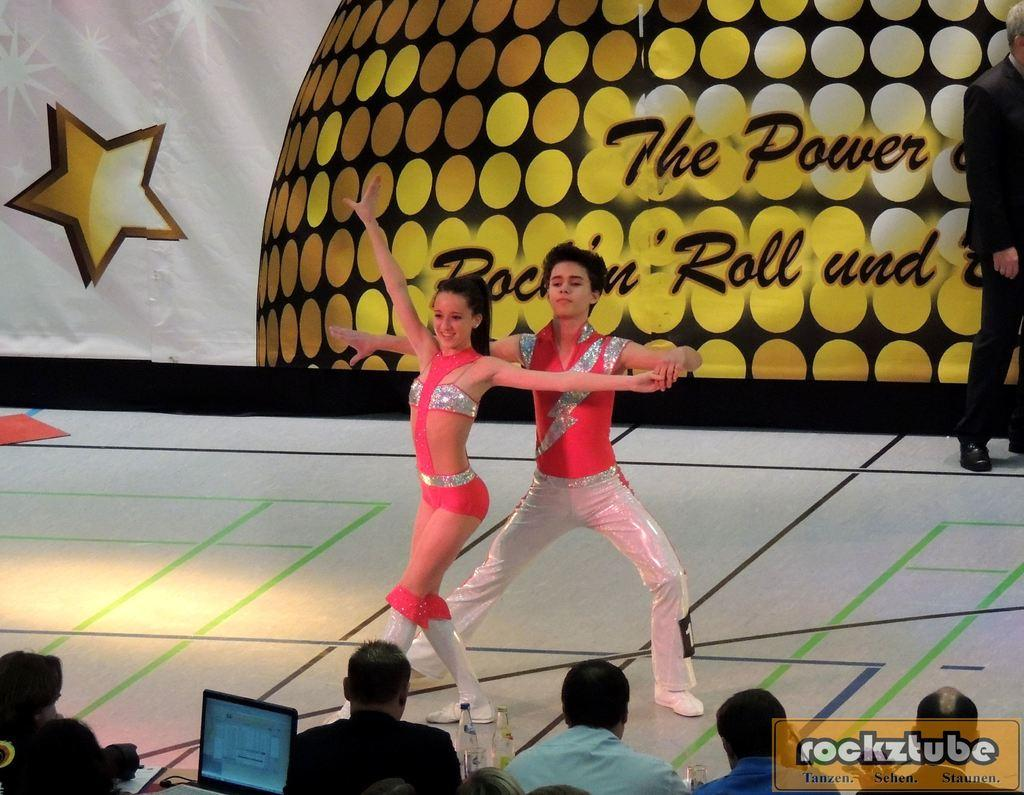What are the two persons on the stage doing? The two persons on the stage are dancing. What can be seen in front of the stage? There is a group of people in front of the stage. Can you identify any electronic device in the image? Yes, a laptop is visible in the image. What is present in the background of the image? There is a banner in the background of the image. How many apples are being used as chairs by the group of people in the image? There are no apples or chairs present in the image. 